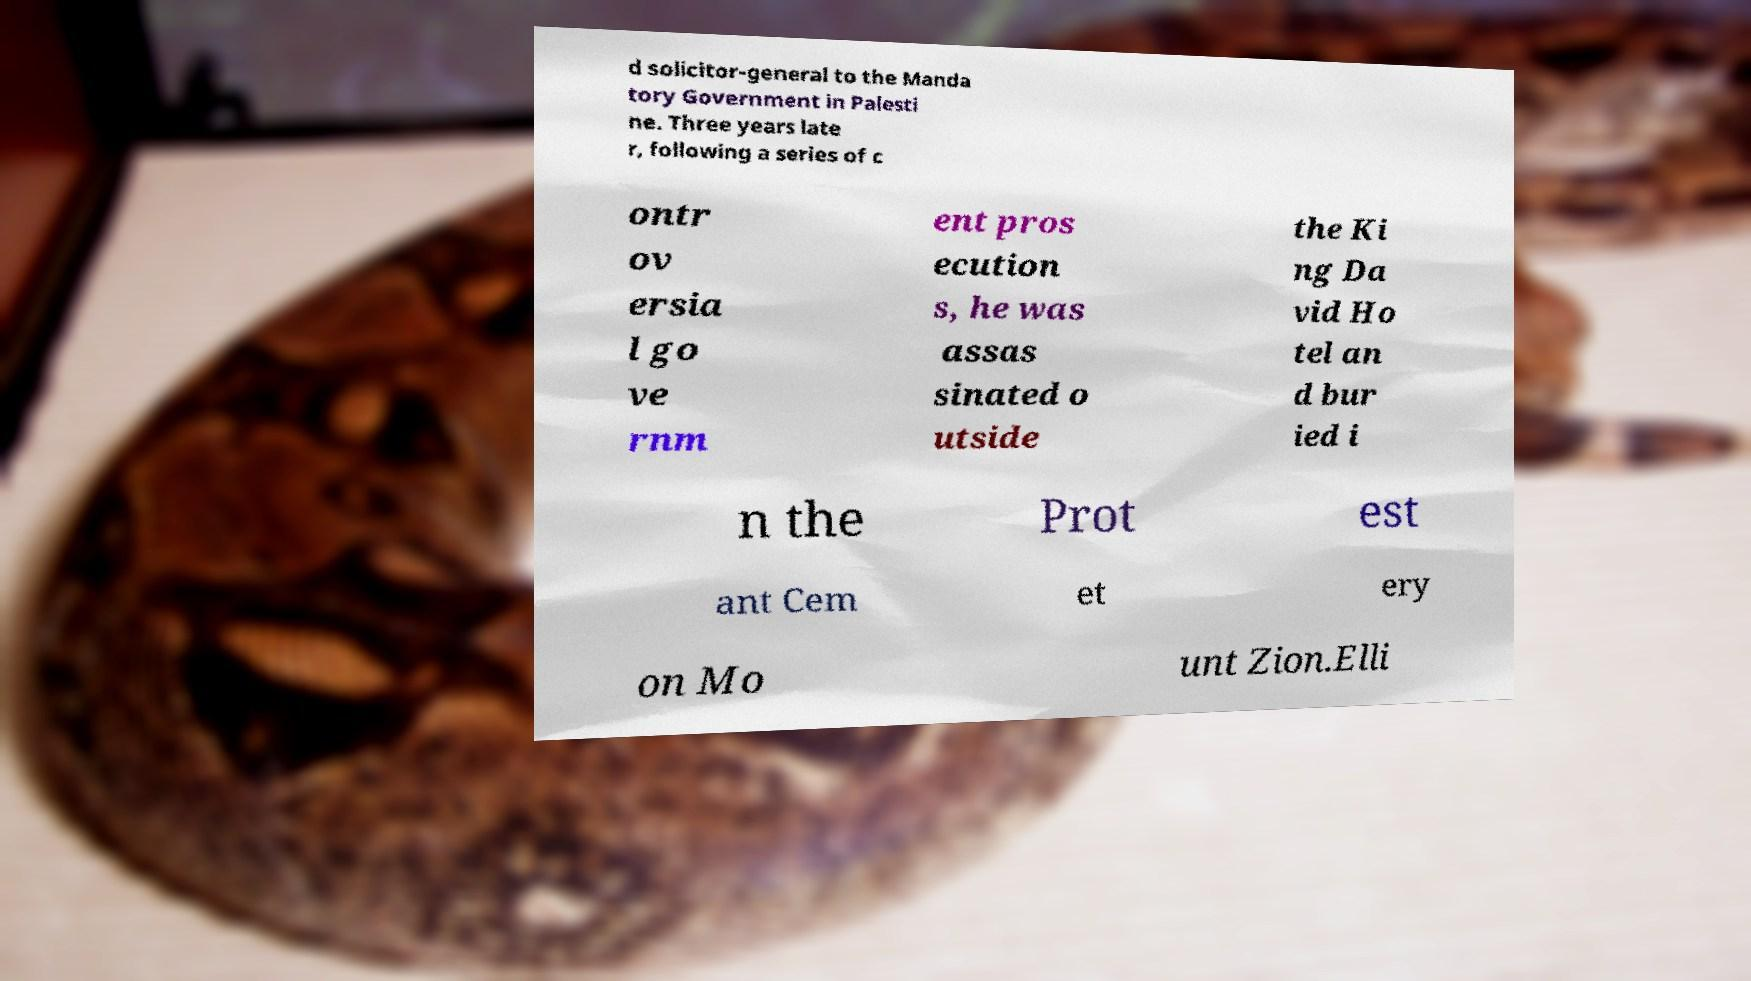Can you accurately transcribe the text from the provided image for me? d solicitor-general to the Manda tory Government in Palesti ne. Three years late r, following a series of c ontr ov ersia l go ve rnm ent pros ecution s, he was assas sinated o utside the Ki ng Da vid Ho tel an d bur ied i n the Prot est ant Cem et ery on Mo unt Zion.Elli 